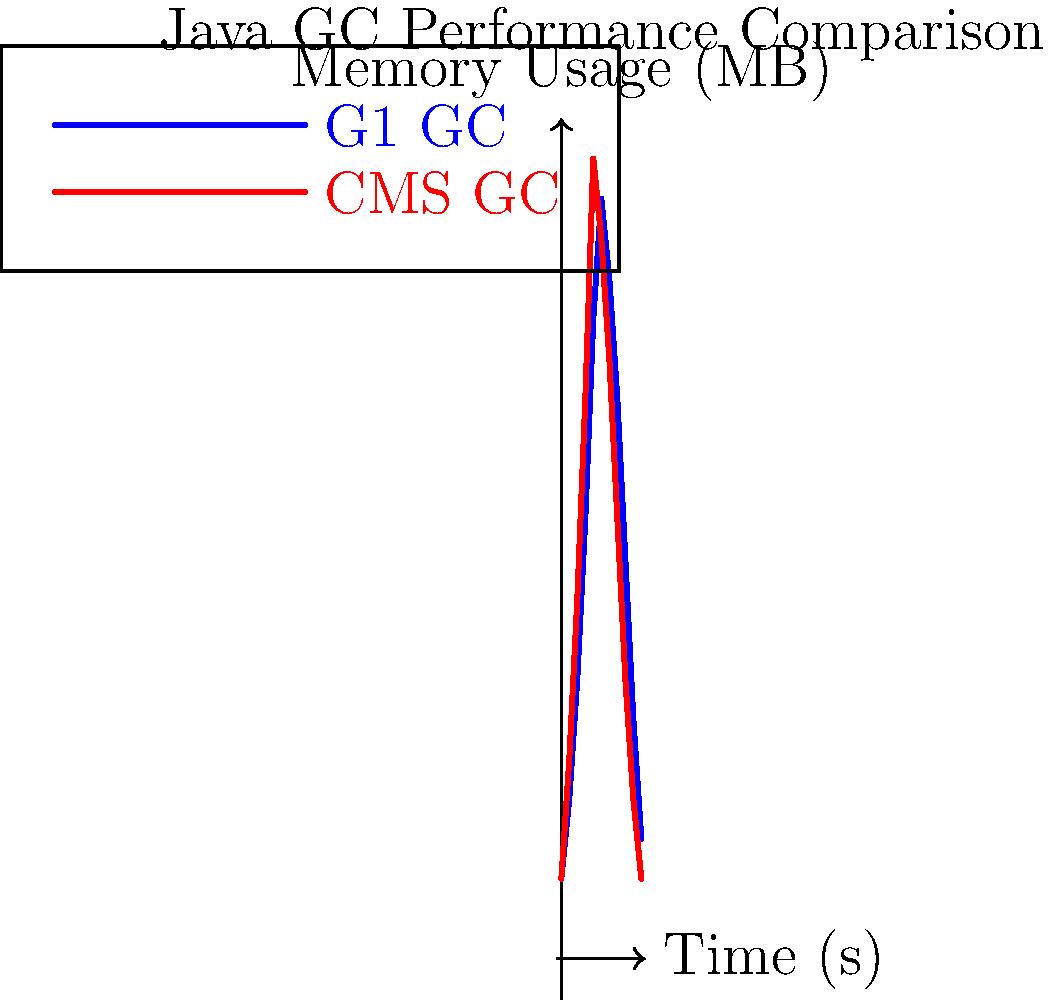Analyze the memory usage graphs of two garbage collection algorithms in Java: G1 (Garbage First) and CMS (Concurrent Mark Sweep). Which algorithm appears to have a more consistent memory usage pattern and why might this be advantageous in a low-latency messaging system like Aeron? To analyze the performance impact of different garbage collection algorithms and their suitability for a low-latency messaging system like Aeron, we need to consider several factors:

1. Memory usage pattern:
   - G1 GC (blue line): Shows a more gradual increase and decrease in memory usage.
   - CMS GC (red line): Exhibits sharper spikes and drops in memory usage.

2. Peak memory usage:
   - G1 GC: Reaches a lower peak (around 95 MB) compared to CMS.
   - CMS GC: Has a higher peak (100 MB) and more abrupt changes.

3. Consistency:
   - G1 GC: Demonstrates a smoother, more consistent pattern overall.
   - CMS GC: Shows more variability and sudden changes in memory usage.

4. Impact on low-latency systems:
   - In a low-latency messaging system like Aeron, consistent performance is crucial to minimize latency spikes and maintain predictable behavior.
   - Large, sudden changes in memory usage can lead to stop-the-world pauses, which can significantly impact latency.

5. Advantages of G1 GC for Aeron:
   - More predictable memory usage patterns lead to more consistent application performance.
   - Lower peak memory usage may result in better overall resource utilization.
   - Smoother transitions between collection cycles can help reduce the likelihood of long pauses.

6. Potential drawbacks of CMS for Aeron:
   - Sharp spikes and drops in memory usage may indicate longer pause times during collection.
   - Higher variability in memory usage could lead to less predictable application behavior.
   - The higher peak memory usage might require more memory allocation, potentially impacting system resources.

Given these considerations, the G1 (Garbage First) collector appears to have a more consistent memory usage pattern, which would be advantageous for a low-latency messaging system like Aeron. The smoother pattern suggests fewer and shorter pause times, leading to more predictable performance and reduced latency spikes.
Answer: G1 GC; more consistent memory usage pattern reduces latency spikes in low-latency systems. 